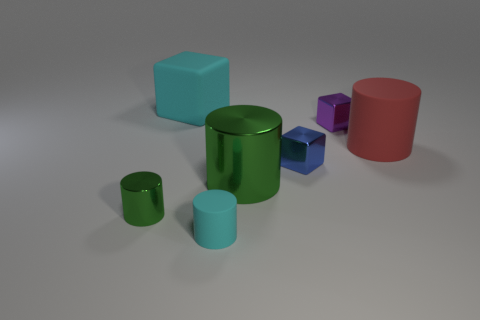Subtract all red cylinders. Subtract all purple cubes. How many cylinders are left? 3 Add 2 cyan rubber cylinders. How many objects exist? 9 Subtract all cylinders. How many objects are left? 3 Subtract all green metallic things. Subtract all tiny cyan things. How many objects are left? 4 Add 4 tiny purple cubes. How many tiny purple cubes are left? 5 Add 7 tiny blue metallic blocks. How many tiny blue metallic blocks exist? 8 Subtract 0 gray balls. How many objects are left? 7 